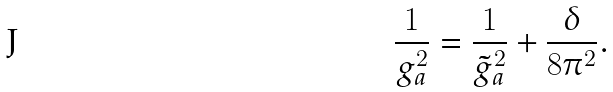<formula> <loc_0><loc_0><loc_500><loc_500>\frac { 1 } { g _ { a } ^ { 2 } } = \frac { 1 } { { \tilde { g } } _ { a } ^ { 2 } } + \frac { \delta } { 8 \pi ^ { 2 } } .</formula> 